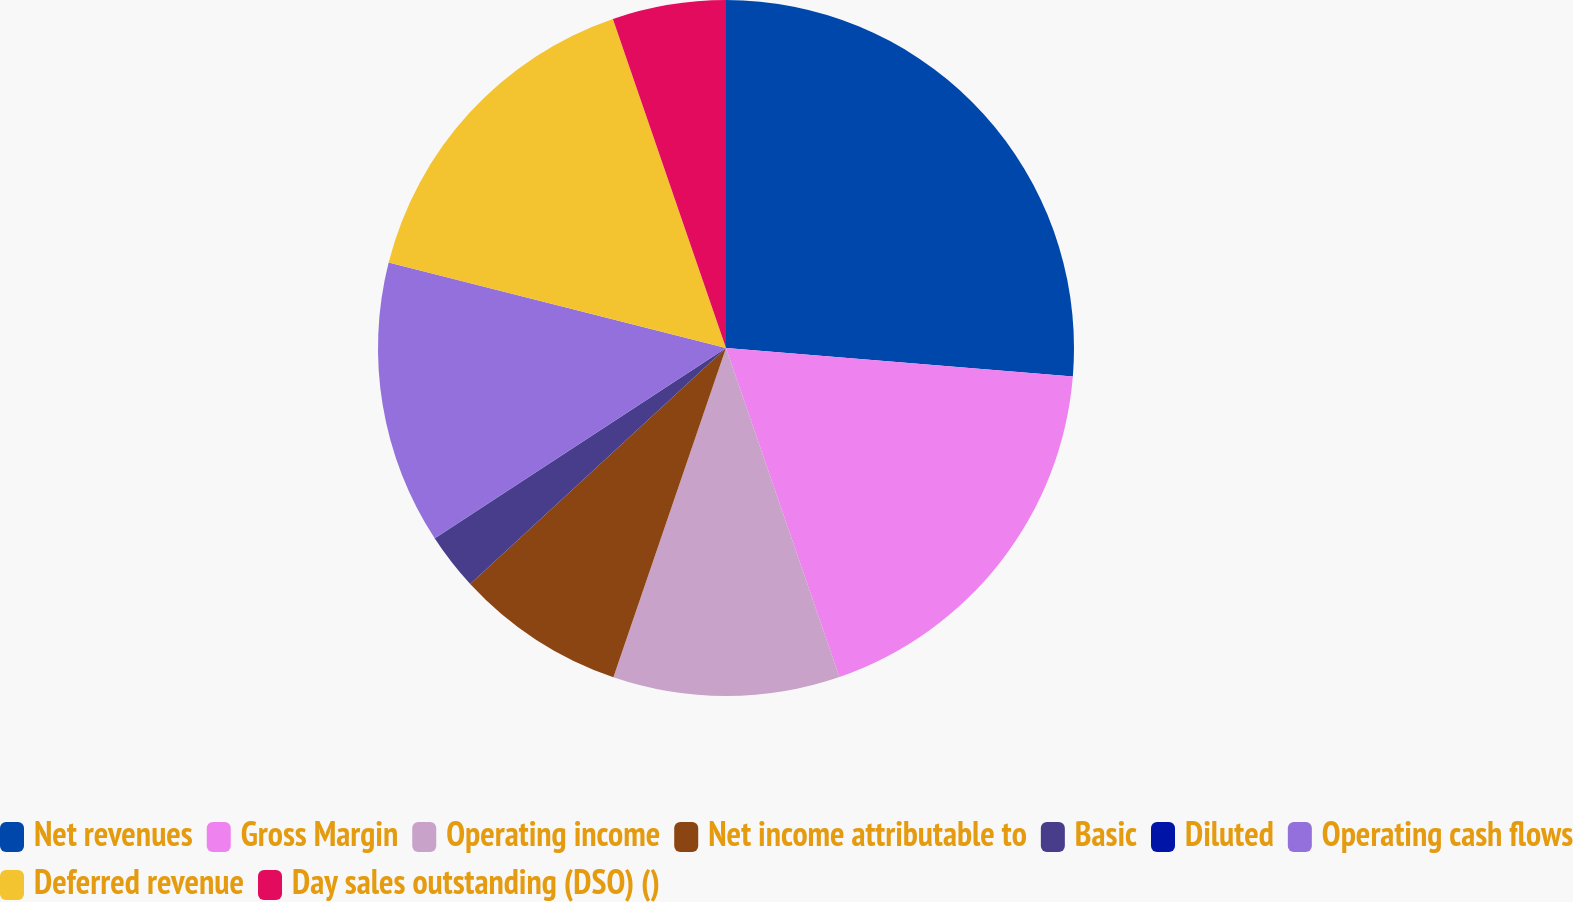Convert chart. <chart><loc_0><loc_0><loc_500><loc_500><pie_chart><fcel>Net revenues<fcel>Gross Margin<fcel>Operating income<fcel>Net income attributable to<fcel>Basic<fcel>Diluted<fcel>Operating cash flows<fcel>Deferred revenue<fcel>Day sales outstanding (DSO) ()<nl><fcel>26.31%<fcel>18.42%<fcel>10.53%<fcel>7.9%<fcel>2.64%<fcel>0.01%<fcel>13.16%<fcel>15.79%<fcel>5.27%<nl></chart> 